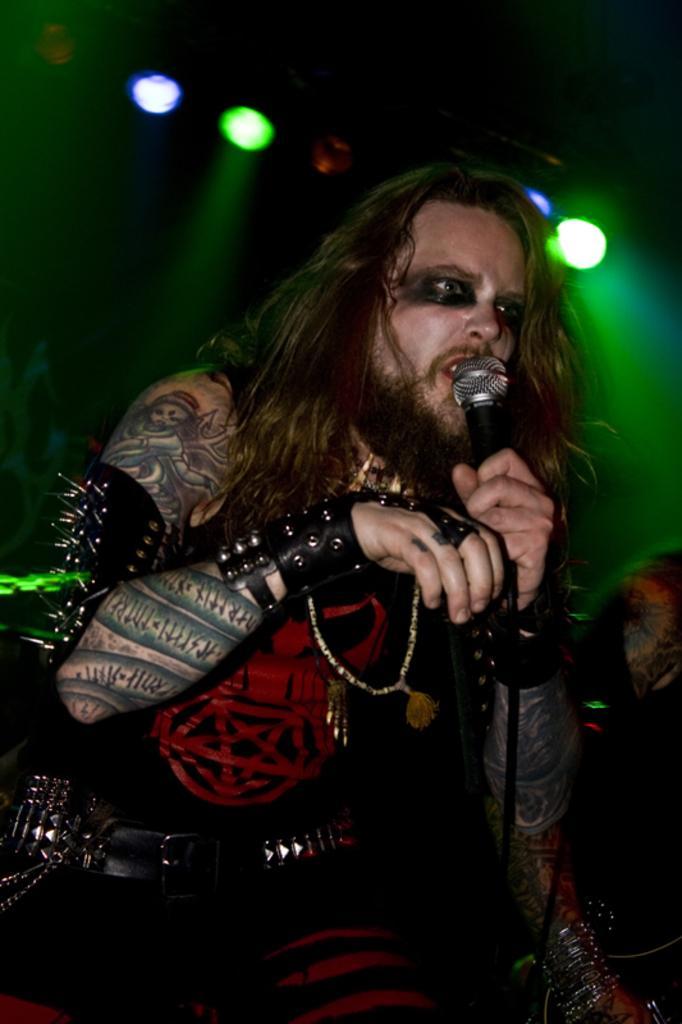Please provide a concise description of this image. In the image we can see there is a man and he is holding mic in his hand. Behind there are lightings on the top. 